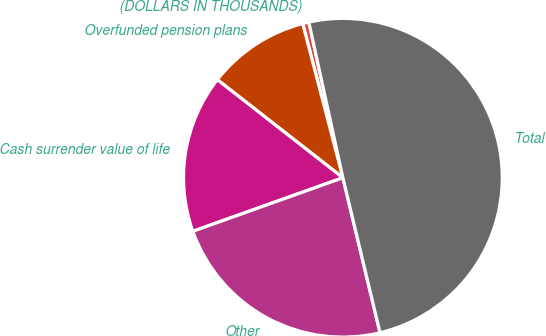Convert chart. <chart><loc_0><loc_0><loc_500><loc_500><pie_chart><fcel>(DOLLARS IN THOUSANDS)<fcel>Overfunded pension plans<fcel>Cash surrender value of life<fcel>Other<fcel>Total<nl><fcel>0.63%<fcel>10.39%<fcel>16.01%<fcel>23.29%<fcel>49.69%<nl></chart> 